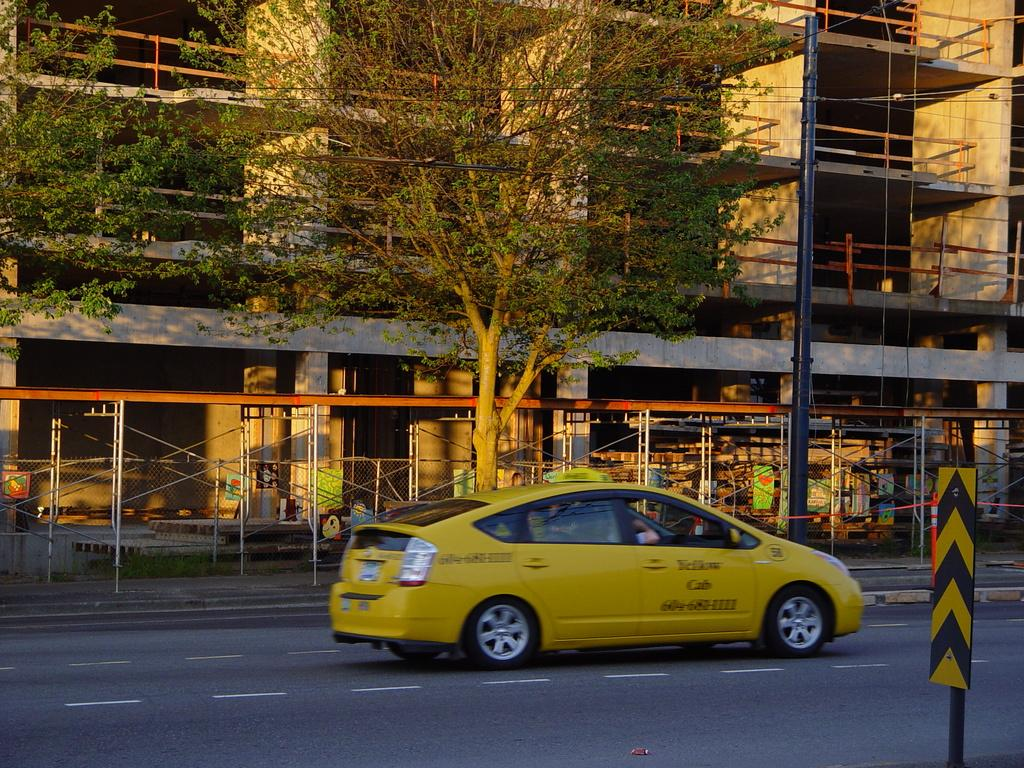<image>
Relay a brief, clear account of the picture shown. a Yellow Cab company cab on the street of a public place. 